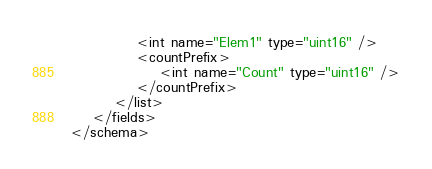Convert code to text. <code><loc_0><loc_0><loc_500><loc_500><_XML_>            <int name="Elem1" type="uint16" />
            <countPrefix>
                <int name="Count" type="uint16" />
            </countPrefix>
        </list>
    </fields>
</schema>
</code> 